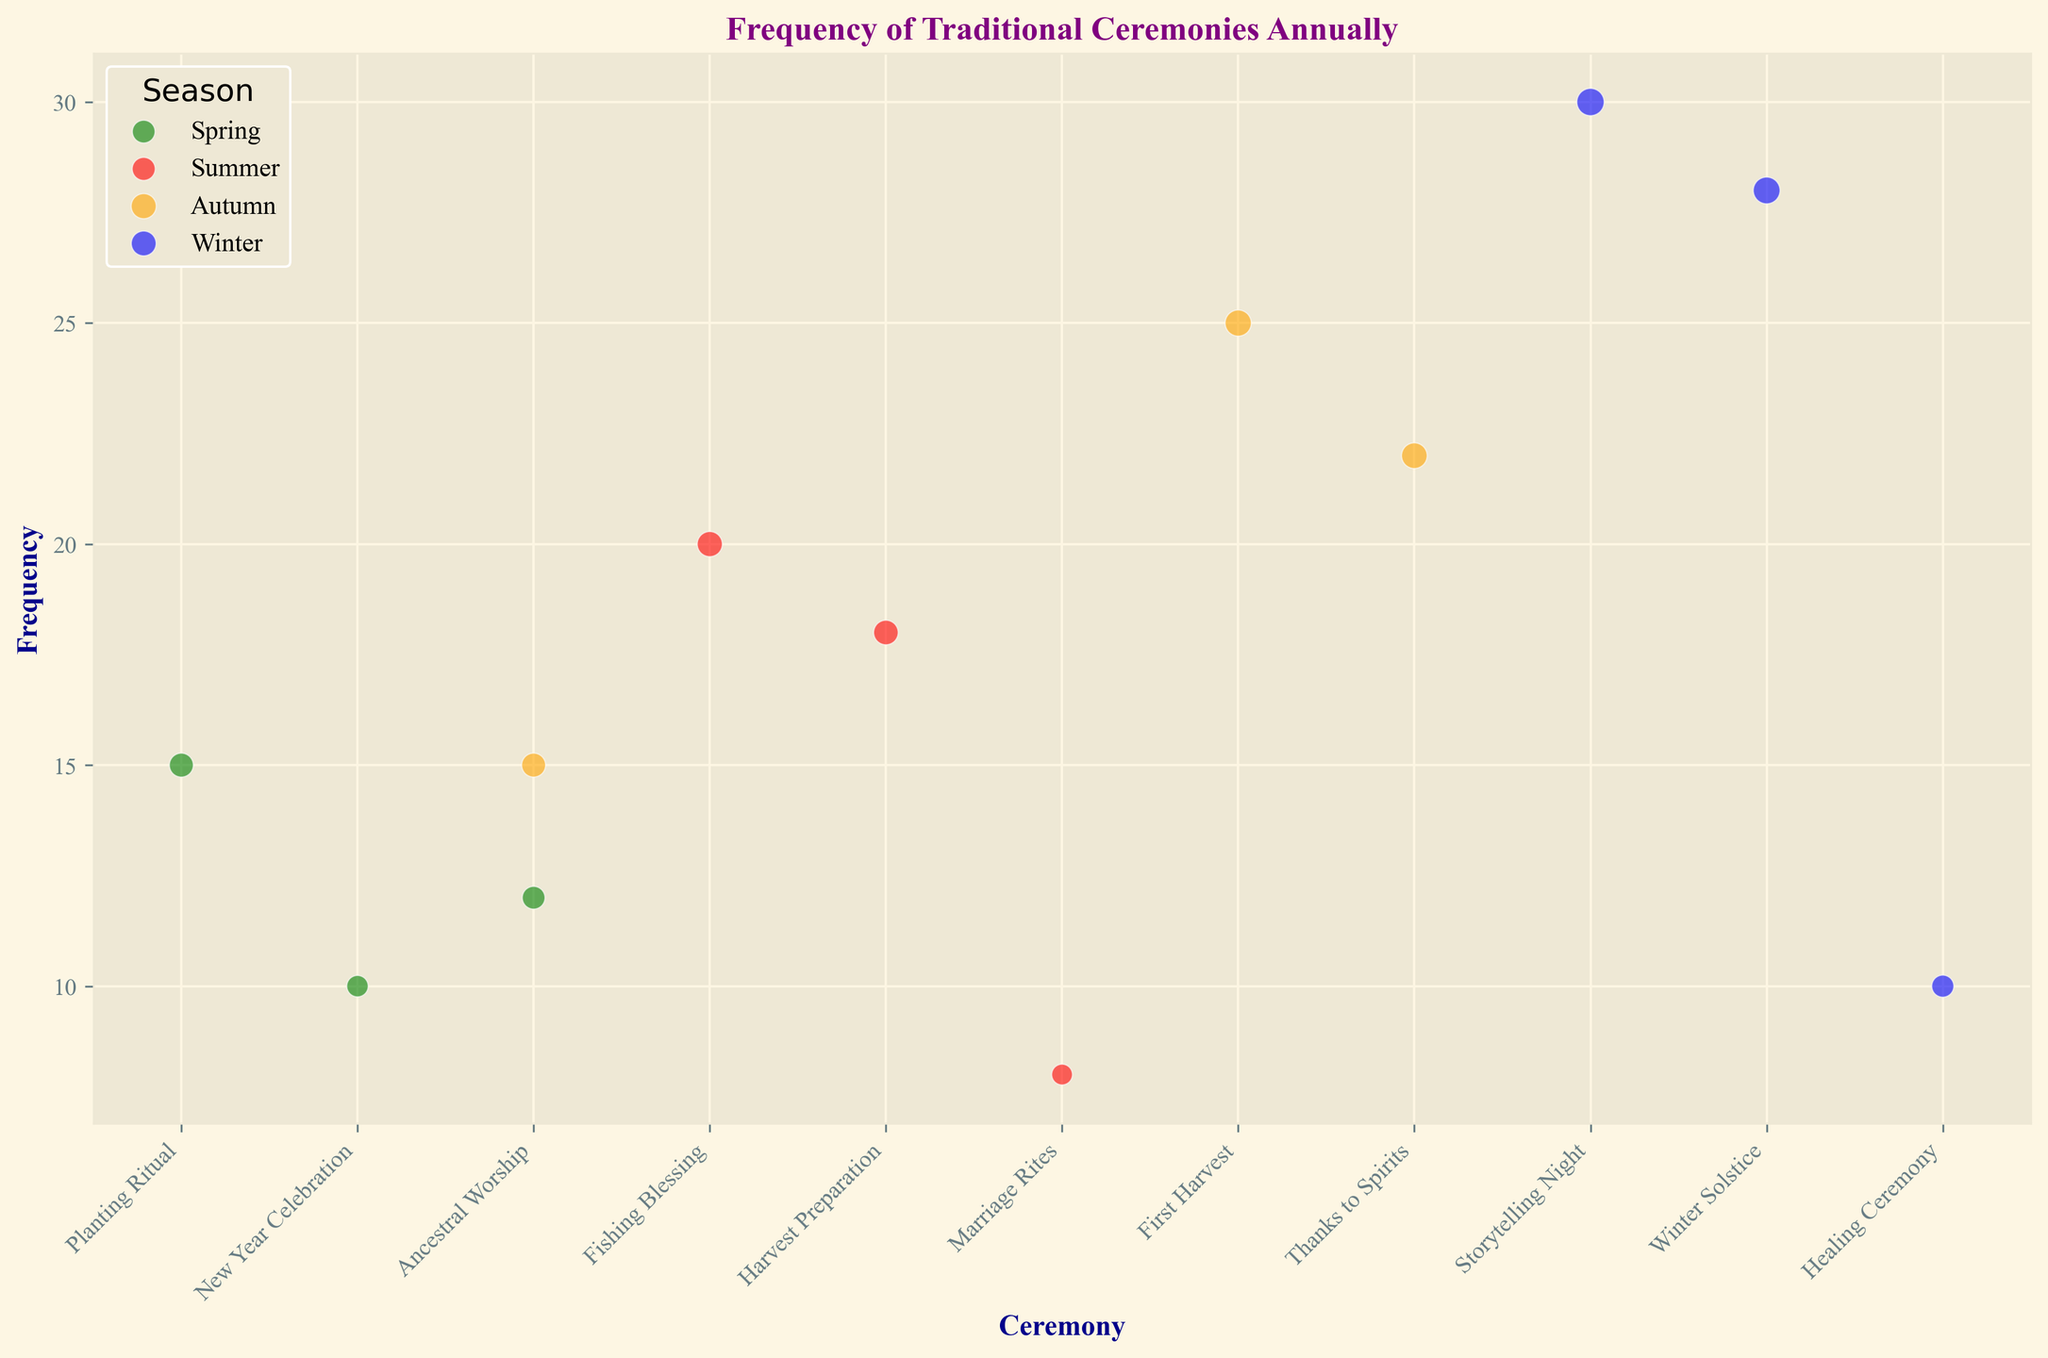what is the most frequent ceremony in winter? to find the most frequent ceremony in winter, we look at the "Frequency" values for "Winter" and identify the highest value. "Storytelling Night" has the frequency value of 30 which is the highest among winter ceremonies.
Answer: Storytelling Night what ceremony has the largest bubble size in autumn? to find this, look at the bubble sizes in autumn. "First Harvest" has a size of 120 which is the largest bubble size for autumn ceremonies.
Answer: First Harvest compare the frequency of "New Year Celebration" in spring and "Marriage Rites" in summer, which one is higher? look at the "New Year Celebration" frequency in spring which is 10, and "Marriage Rites" frequency in summer which is 8. "New Year Celebration" is higher.
Answer: New Year Celebration which season sees the highest frequency for "Ancestral Worship"? compare the frequency of "Ancestral Worship" across seasons. "Ancestral Worship" appears in spring with a frequency of 12, and in autumn with a frequency of 15. The highest frequency is in autumn.
Answer: Autumn what is the least frequent ceremony in summer? look at all the frequency values for summer ceremonies. "Marriage Rites" has the lowest frequency with a value of 8.
Answer: Marriage Rites among the "Thanks to Spirits" and "Healing Ceremony," which one occurs more frequently? compare the frequencies of "Thanks to Spirits" (22) and "Healing Ceremony" (10). "Thanks to Spirits" occurs more frequently.
Answer: Thanks to Spirits what is the total frequency of all ceremonies in winter? sum the frequencies of winter ceremonies: Storytelling Night (30), Winter Solstice (28), and Healing Ceremony (10). Total frequency is 30 + 28 + 10 = 68.
Answer: 68 if we merge "Fishing Blessing" and "Harvest Preparation" into one ceremony, what would its frequency and bubble size be? sum the frequencies of "Fishing Blessing" (20) and "Harvest Preparation" (18), resulting in 38. The bubble sizes would be summed similarly, resulting in 110 + 105 = 215.
Answer: Frequency: 38, Size: 215 what color represents the "New Year Celebration"? the color of the bubbles representing "New Year Celebration" is green, as it is in spring.
Answer: Green is the average bubble size in winter ceremonies larger than the average bubble size in spring ceremonies? calculate the average bubble size for winter: (130 + 125 + 85)/3 ≈ 113.33. For spring: (100 + 80 + 90)/3 ≈ 90. Therefore, the average bubble size in winter is larger.
Answer: Yes 